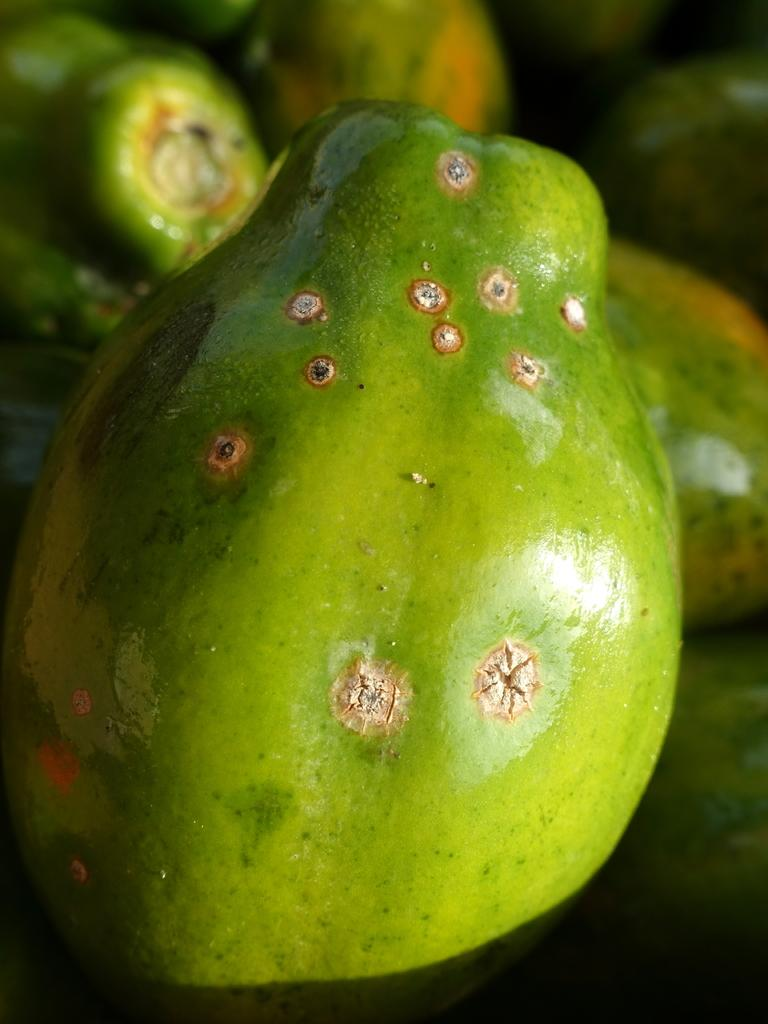What type of fruits are present in the image? There are unripe fruits in the image. What verse can be heard recited by the snail in the image? There is no snail or verse present in the image; it only features unripe fruits. 